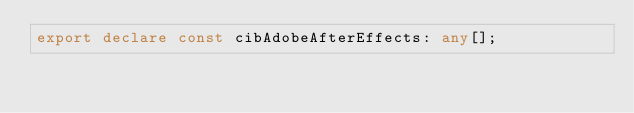Convert code to text. <code><loc_0><loc_0><loc_500><loc_500><_TypeScript_>export declare const cibAdobeAfterEffects: any[];</code> 